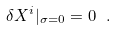<formula> <loc_0><loc_0><loc_500><loc_500>\delta X ^ { i } | _ { \sigma = 0 } = 0 \ .</formula> 